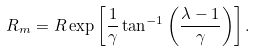Convert formula to latex. <formula><loc_0><loc_0><loc_500><loc_500>R _ { m } = R \exp \left [ \frac { 1 } { \gamma } \tan ^ { - 1 } \left ( \frac { \lambda - 1 } { \gamma } \right ) \right ] .</formula> 